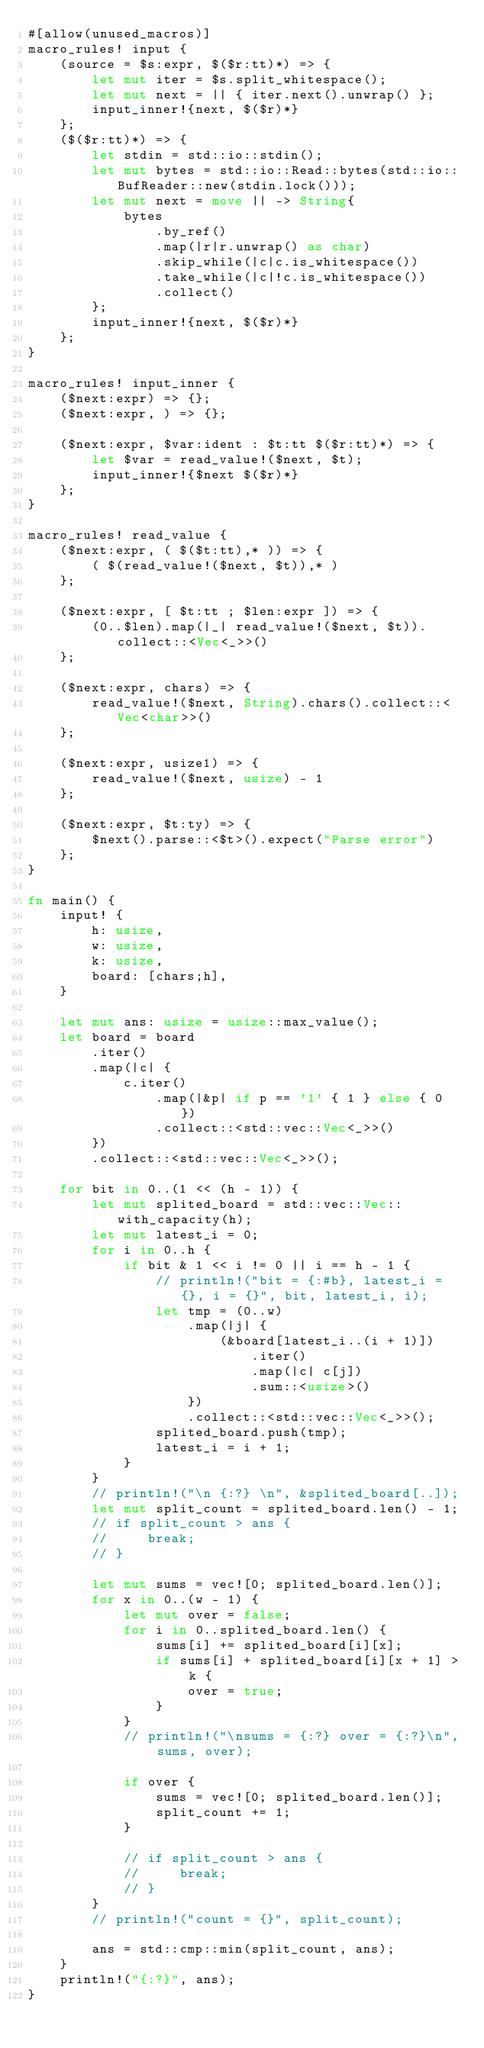<code> <loc_0><loc_0><loc_500><loc_500><_Rust_>#[allow(unused_macros)]
macro_rules! input {
    (source = $s:expr, $($r:tt)*) => {
        let mut iter = $s.split_whitespace();
        let mut next = || { iter.next().unwrap() };
        input_inner!{next, $($r)*}
    };
    ($($r:tt)*) => {
        let stdin = std::io::stdin();
        let mut bytes = std::io::Read::bytes(std::io::BufReader::new(stdin.lock()));
        let mut next = move || -> String{
            bytes
                .by_ref()
                .map(|r|r.unwrap() as char)
                .skip_while(|c|c.is_whitespace())
                .take_while(|c|!c.is_whitespace())
                .collect()
        };
        input_inner!{next, $($r)*}
    };
}

macro_rules! input_inner {
    ($next:expr) => {};
    ($next:expr, ) => {};

    ($next:expr, $var:ident : $t:tt $($r:tt)*) => {
        let $var = read_value!($next, $t);
        input_inner!{$next $($r)*}
    };
}

macro_rules! read_value {
    ($next:expr, ( $($t:tt),* )) => {
        ( $(read_value!($next, $t)),* )
    };

    ($next:expr, [ $t:tt ; $len:expr ]) => {
        (0..$len).map(|_| read_value!($next, $t)).collect::<Vec<_>>()
    };

    ($next:expr, chars) => {
        read_value!($next, String).chars().collect::<Vec<char>>()
    };

    ($next:expr, usize1) => {
        read_value!($next, usize) - 1
    };

    ($next:expr, $t:ty) => {
        $next().parse::<$t>().expect("Parse error")
    };
}

fn main() {
    input! {
        h: usize,
        w: usize,
        k: usize,
        board: [chars;h],
    }

    let mut ans: usize = usize::max_value();
    let board = board
        .iter()
        .map(|c| {
            c.iter()
                .map(|&p| if p == '1' { 1 } else { 0 })
                .collect::<std::vec::Vec<_>>()
        })
        .collect::<std::vec::Vec<_>>();

    for bit in 0..(1 << (h - 1)) {
        let mut splited_board = std::vec::Vec::with_capacity(h);
        let mut latest_i = 0;
        for i in 0..h {
            if bit & 1 << i != 0 || i == h - 1 {
                // println!("bit = {:#b}, latest_i = {}, i = {}", bit, latest_i, i);
                let tmp = (0..w)
                    .map(|j| {
                        (&board[latest_i..(i + 1)])
                            .iter()
                            .map(|c| c[j])
                            .sum::<usize>()
                    })
                    .collect::<std::vec::Vec<_>>();
                splited_board.push(tmp);
                latest_i = i + 1;
            }
        }
        // println!("\n {:?} \n", &splited_board[..]);
        let mut split_count = splited_board.len() - 1;
        // if split_count > ans {
        //     break;
        // }

        let mut sums = vec![0; splited_board.len()];
        for x in 0..(w - 1) {
            let mut over = false;
            for i in 0..splited_board.len() {
                sums[i] += splited_board[i][x];
                if sums[i] + splited_board[i][x + 1] > k {
                    over = true;
                }
            }
            // println!("\nsums = {:?} over = {:?}\n", sums, over);

            if over {
                sums = vec![0; splited_board.len()];
                split_count += 1;
            }

            // if split_count > ans {
            //     break;
            // }
        }
        // println!("count = {}", split_count);

        ans = std::cmp::min(split_count, ans);
    }
    println!("{:?}", ans);
}
</code> 